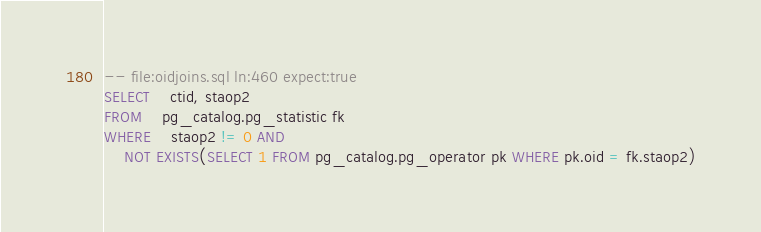<code> <loc_0><loc_0><loc_500><loc_500><_SQL_>-- file:oidjoins.sql ln:460 expect:true
SELECT	ctid, staop2
FROM	pg_catalog.pg_statistic fk
WHERE	staop2 != 0 AND
	NOT EXISTS(SELECT 1 FROM pg_catalog.pg_operator pk WHERE pk.oid = fk.staop2)
</code> 